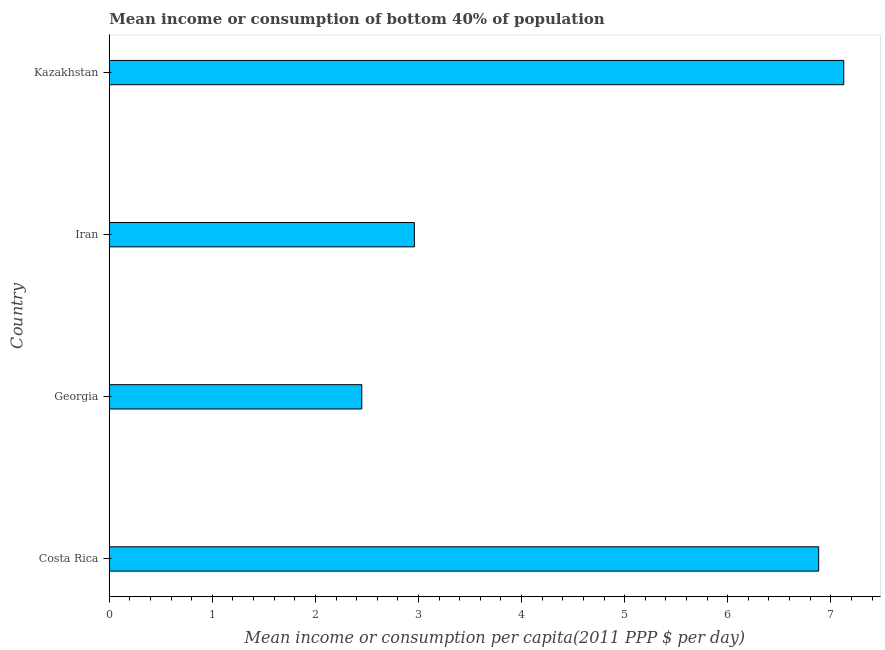What is the title of the graph?
Ensure brevity in your answer.  Mean income or consumption of bottom 40% of population. What is the label or title of the X-axis?
Your answer should be compact. Mean income or consumption per capita(2011 PPP $ per day). What is the mean income or consumption in Costa Rica?
Your response must be concise. 6.88. Across all countries, what is the maximum mean income or consumption?
Offer a terse response. 7.13. Across all countries, what is the minimum mean income or consumption?
Provide a short and direct response. 2.45. In which country was the mean income or consumption maximum?
Offer a very short reply. Kazakhstan. In which country was the mean income or consumption minimum?
Your response must be concise. Georgia. What is the sum of the mean income or consumption?
Your answer should be very brief. 19.42. What is the difference between the mean income or consumption in Georgia and Iran?
Provide a succinct answer. -0.51. What is the average mean income or consumption per country?
Provide a short and direct response. 4.86. What is the median mean income or consumption?
Your answer should be very brief. 4.92. In how many countries, is the mean income or consumption greater than 3.8 $?
Ensure brevity in your answer.  2. What is the ratio of the mean income or consumption in Costa Rica to that in Georgia?
Give a very brief answer. 2.81. Is the difference between the mean income or consumption in Costa Rica and Kazakhstan greater than the difference between any two countries?
Your response must be concise. No. What is the difference between the highest and the second highest mean income or consumption?
Ensure brevity in your answer.  0.24. What is the difference between the highest and the lowest mean income or consumption?
Your response must be concise. 4.68. In how many countries, is the mean income or consumption greater than the average mean income or consumption taken over all countries?
Your answer should be compact. 2. Are the values on the major ticks of X-axis written in scientific E-notation?
Provide a succinct answer. No. What is the Mean income or consumption per capita(2011 PPP $ per day) of Costa Rica?
Offer a very short reply. 6.88. What is the Mean income or consumption per capita(2011 PPP $ per day) of Georgia?
Your answer should be very brief. 2.45. What is the Mean income or consumption per capita(2011 PPP $ per day) in Iran?
Ensure brevity in your answer.  2.96. What is the Mean income or consumption per capita(2011 PPP $ per day) in Kazakhstan?
Provide a short and direct response. 7.13. What is the difference between the Mean income or consumption per capita(2011 PPP $ per day) in Costa Rica and Georgia?
Your response must be concise. 4.43. What is the difference between the Mean income or consumption per capita(2011 PPP $ per day) in Costa Rica and Iran?
Give a very brief answer. 3.92. What is the difference between the Mean income or consumption per capita(2011 PPP $ per day) in Costa Rica and Kazakhstan?
Make the answer very short. -0.24. What is the difference between the Mean income or consumption per capita(2011 PPP $ per day) in Georgia and Iran?
Keep it short and to the point. -0.51. What is the difference between the Mean income or consumption per capita(2011 PPP $ per day) in Georgia and Kazakhstan?
Provide a short and direct response. -4.68. What is the difference between the Mean income or consumption per capita(2011 PPP $ per day) in Iran and Kazakhstan?
Provide a succinct answer. -4.17. What is the ratio of the Mean income or consumption per capita(2011 PPP $ per day) in Costa Rica to that in Georgia?
Your response must be concise. 2.81. What is the ratio of the Mean income or consumption per capita(2011 PPP $ per day) in Costa Rica to that in Iran?
Offer a terse response. 2.33. What is the ratio of the Mean income or consumption per capita(2011 PPP $ per day) in Georgia to that in Iran?
Your response must be concise. 0.83. What is the ratio of the Mean income or consumption per capita(2011 PPP $ per day) in Georgia to that in Kazakhstan?
Give a very brief answer. 0.34. What is the ratio of the Mean income or consumption per capita(2011 PPP $ per day) in Iran to that in Kazakhstan?
Provide a short and direct response. 0.41. 